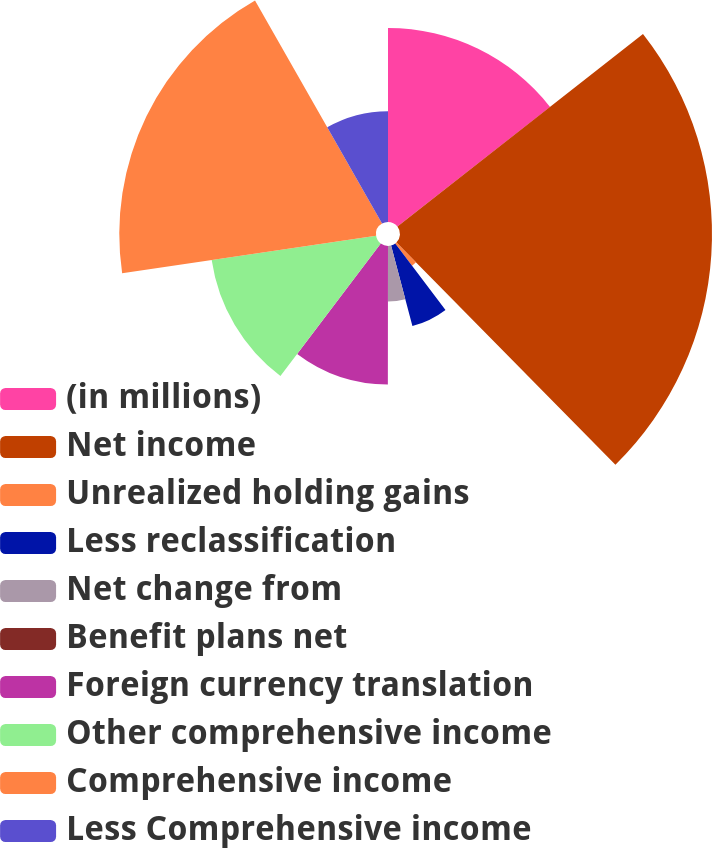Convert chart. <chart><loc_0><loc_0><loc_500><loc_500><pie_chart><fcel>(in millions)<fcel>Net income<fcel>Unrealized holding gains<fcel>Less reclassification<fcel>Net change from<fcel>Benefit plans net<fcel>Foreign currency translation<fcel>Other comprehensive income<fcel>Comprehensive income<fcel>Less Comprehensive income<nl><fcel>14.42%<fcel>23.2%<fcel>2.07%<fcel>6.19%<fcel>4.13%<fcel>0.01%<fcel>10.3%<fcel>12.36%<fcel>19.09%<fcel>8.24%<nl></chart> 